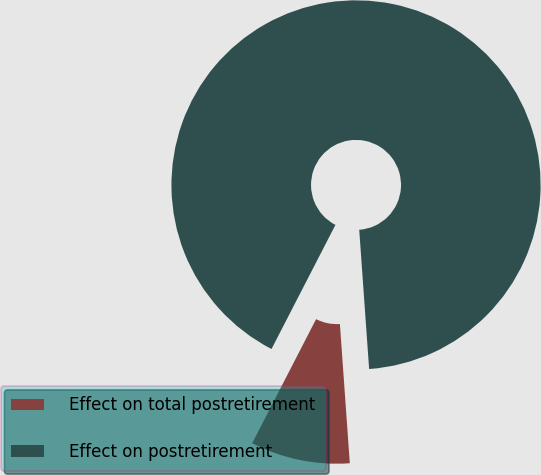Convert chart. <chart><loc_0><loc_0><loc_500><loc_500><pie_chart><fcel>Effect on total postretirement<fcel>Effect on postretirement<nl><fcel>8.7%<fcel>91.3%<nl></chart> 